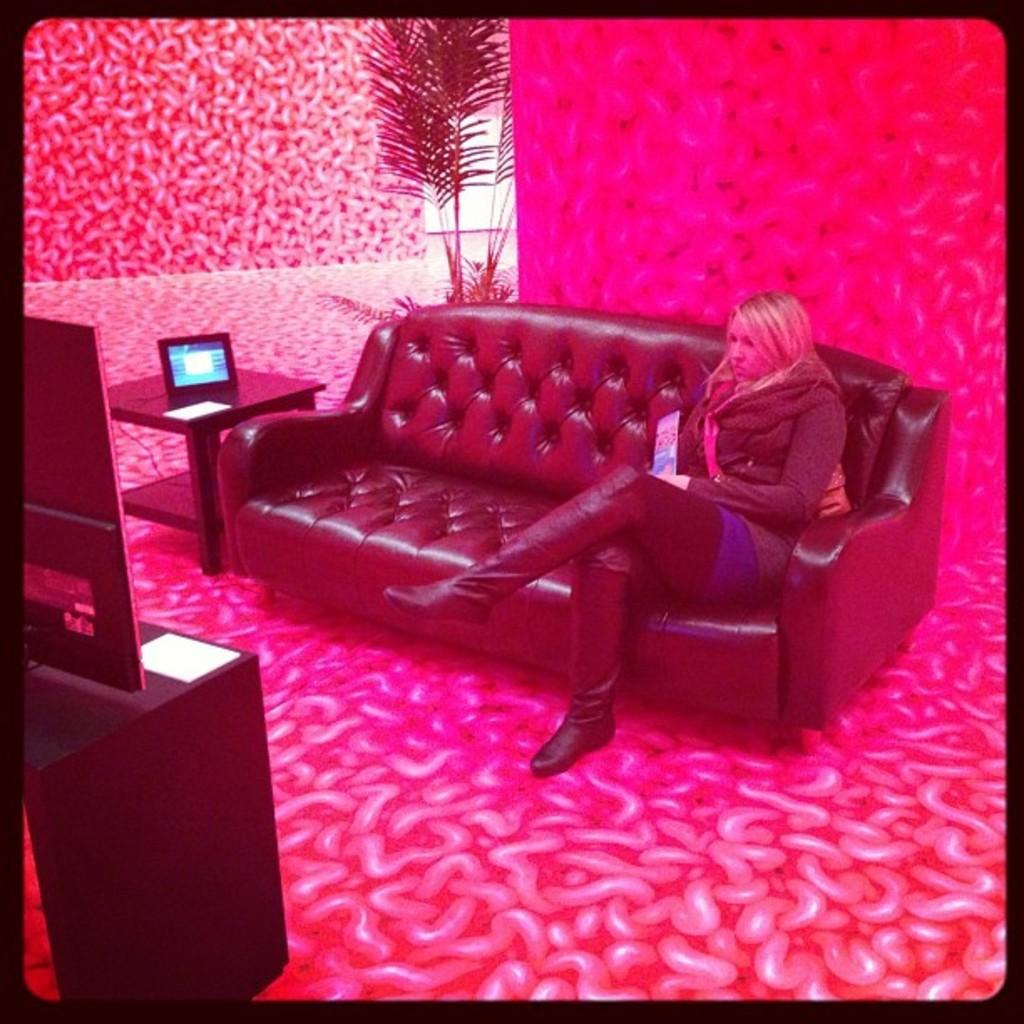Could you give a brief overview of what you see in this image? In this picture we can see a woman sitting on a couch, on the backside of couch we can see a plant, we can see a table behind couch the woman is looking at television, the room is entirely in red color. 